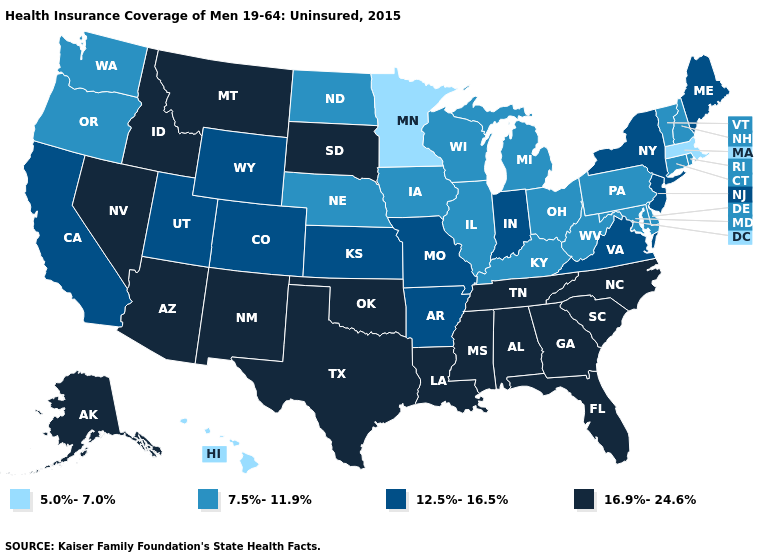Which states have the lowest value in the USA?
Give a very brief answer. Hawaii, Massachusetts, Minnesota. Which states have the lowest value in the South?
Keep it brief. Delaware, Kentucky, Maryland, West Virginia. What is the lowest value in the Northeast?
Keep it brief. 5.0%-7.0%. Does New York have the same value as Kentucky?
Short answer required. No. Which states have the lowest value in the USA?
Give a very brief answer. Hawaii, Massachusetts, Minnesota. Name the states that have a value in the range 5.0%-7.0%?
Keep it brief. Hawaii, Massachusetts, Minnesota. Among the states that border Connecticut , does Rhode Island have the highest value?
Short answer required. No. What is the lowest value in the USA?
Be succinct. 5.0%-7.0%. Which states have the highest value in the USA?
Be succinct. Alabama, Alaska, Arizona, Florida, Georgia, Idaho, Louisiana, Mississippi, Montana, Nevada, New Mexico, North Carolina, Oklahoma, South Carolina, South Dakota, Tennessee, Texas. Among the states that border North Carolina , which have the highest value?
Short answer required. Georgia, South Carolina, Tennessee. Name the states that have a value in the range 7.5%-11.9%?
Write a very short answer. Connecticut, Delaware, Illinois, Iowa, Kentucky, Maryland, Michigan, Nebraska, New Hampshire, North Dakota, Ohio, Oregon, Pennsylvania, Rhode Island, Vermont, Washington, West Virginia, Wisconsin. What is the value of Hawaii?
Quick response, please. 5.0%-7.0%. Does Washington have the same value as Connecticut?
Short answer required. Yes. Name the states that have a value in the range 5.0%-7.0%?
Write a very short answer. Hawaii, Massachusetts, Minnesota. What is the lowest value in the West?
Give a very brief answer. 5.0%-7.0%. 